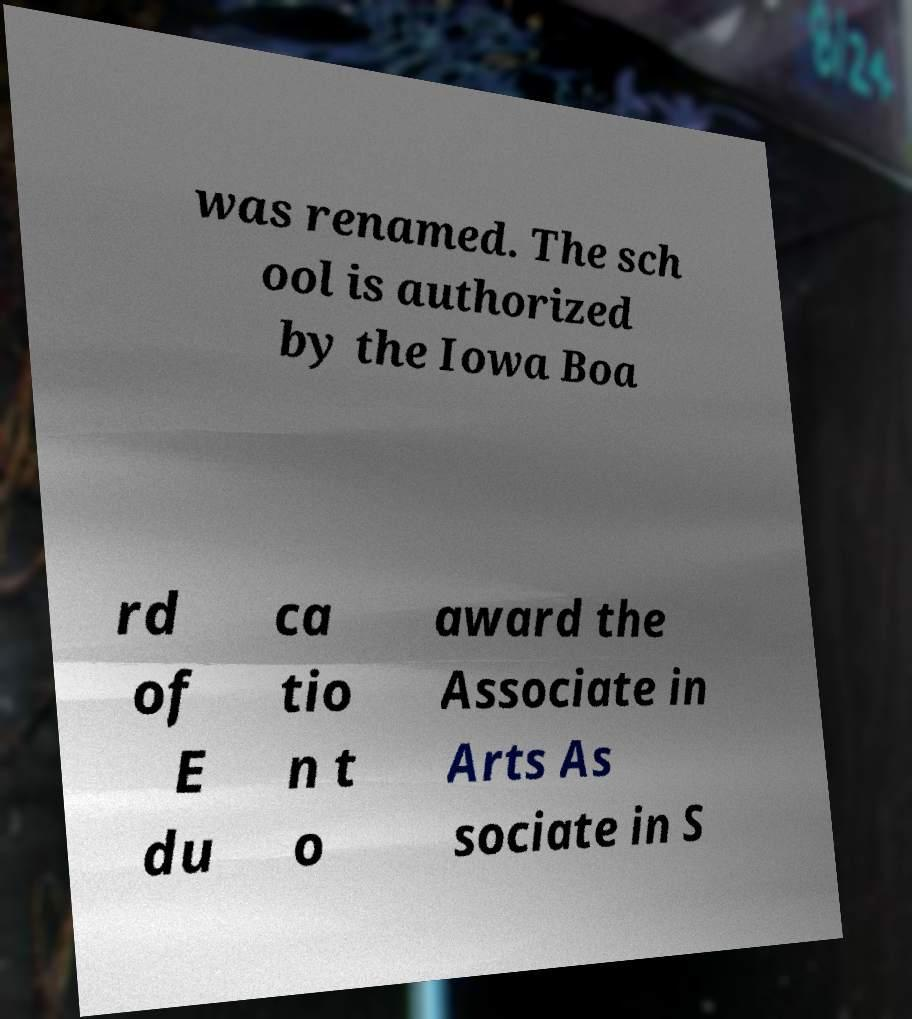For documentation purposes, I need the text within this image transcribed. Could you provide that? was renamed. The sch ool is authorized by the Iowa Boa rd of E du ca tio n t o award the Associate in Arts As sociate in S 